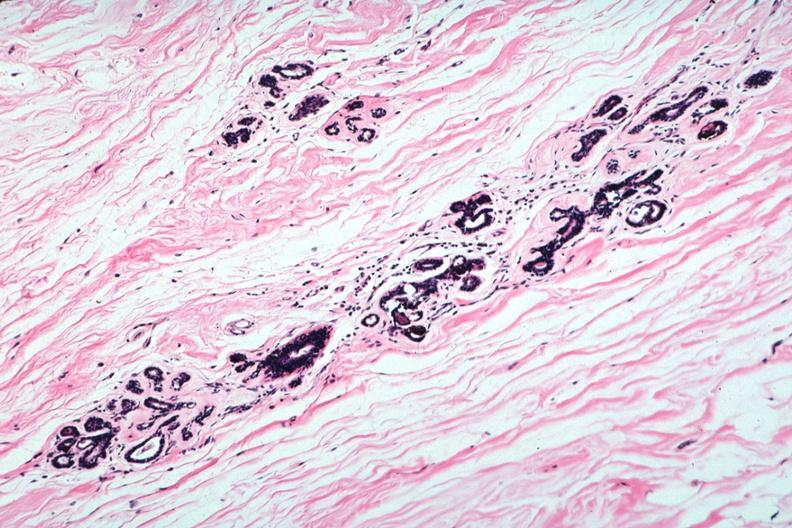what does this image show?
Answer the question using a single word or phrase. Atrophic lobules and normal connective tissue 